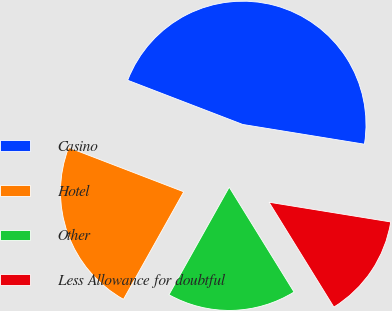<chart> <loc_0><loc_0><loc_500><loc_500><pie_chart><fcel>Casino<fcel>Hotel<fcel>Other<fcel>Less Allowance for doubtful<nl><fcel>46.72%<fcel>22.71%<fcel>16.94%<fcel>13.63%<nl></chart> 